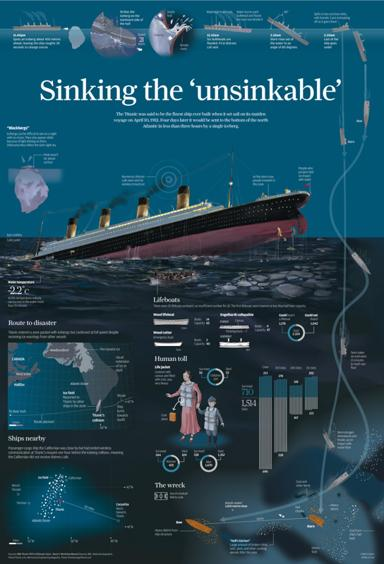What is the main topic of the image?
 The main topic of the image is the sinking of the Titanic, which was often referred to as the "unsinkable" ship. What type of visual representation is depicted in the image? The image contains a Titanic infographic. 